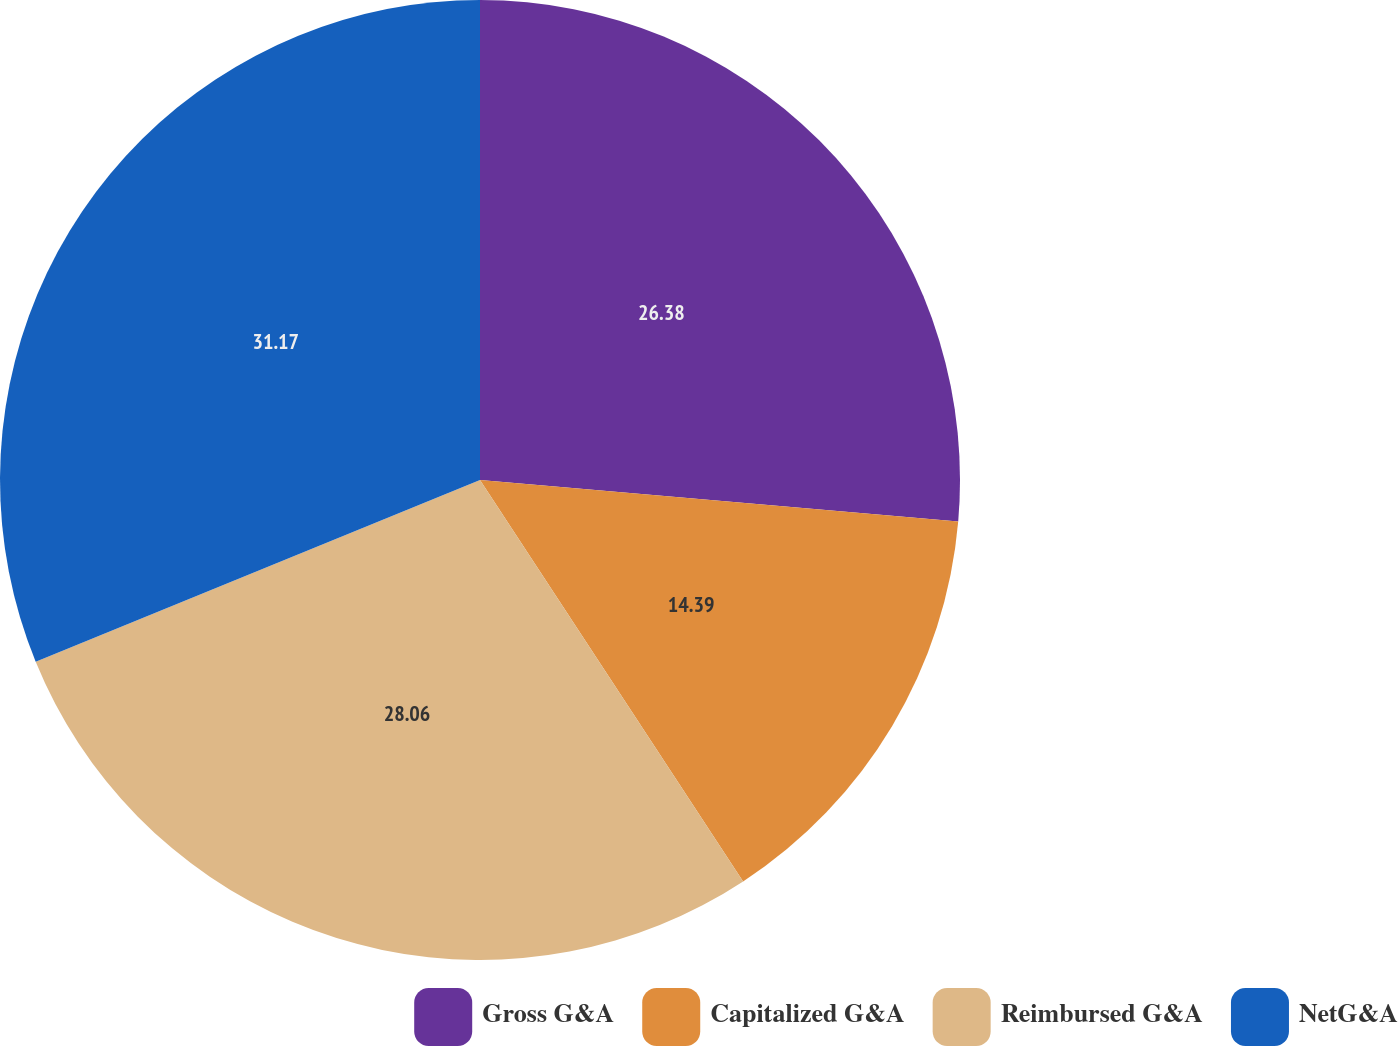Convert chart. <chart><loc_0><loc_0><loc_500><loc_500><pie_chart><fcel>Gross G&A<fcel>Capitalized G&A<fcel>Reimbursed G&A<fcel>NetG&A<nl><fcel>26.38%<fcel>14.39%<fcel>28.06%<fcel>31.18%<nl></chart> 